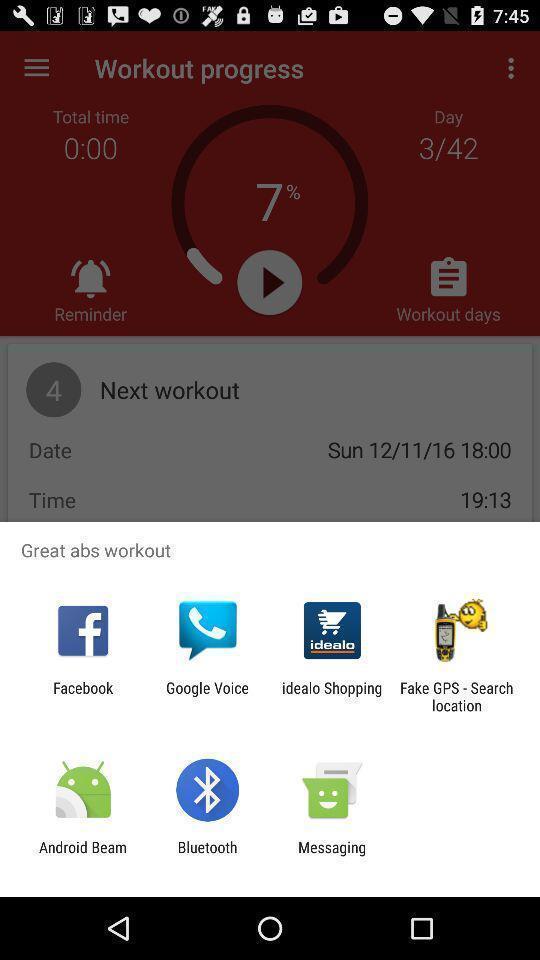Explain the elements present in this screenshot. Pop-up showing the various application. 